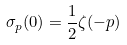Convert formula to latex. <formula><loc_0><loc_0><loc_500><loc_500>\sigma _ { p } ( 0 ) = \frac { 1 } { 2 } \zeta ( - p )</formula> 